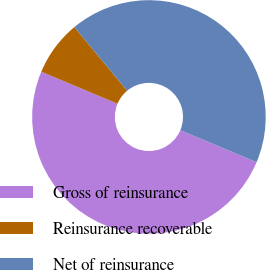Convert chart to OTSL. <chart><loc_0><loc_0><loc_500><loc_500><pie_chart><fcel>Gross of reinsurance<fcel>Reinsurance recoverable<fcel>Net of reinsurance<nl><fcel>50.0%<fcel>7.64%<fcel>42.36%<nl></chart> 